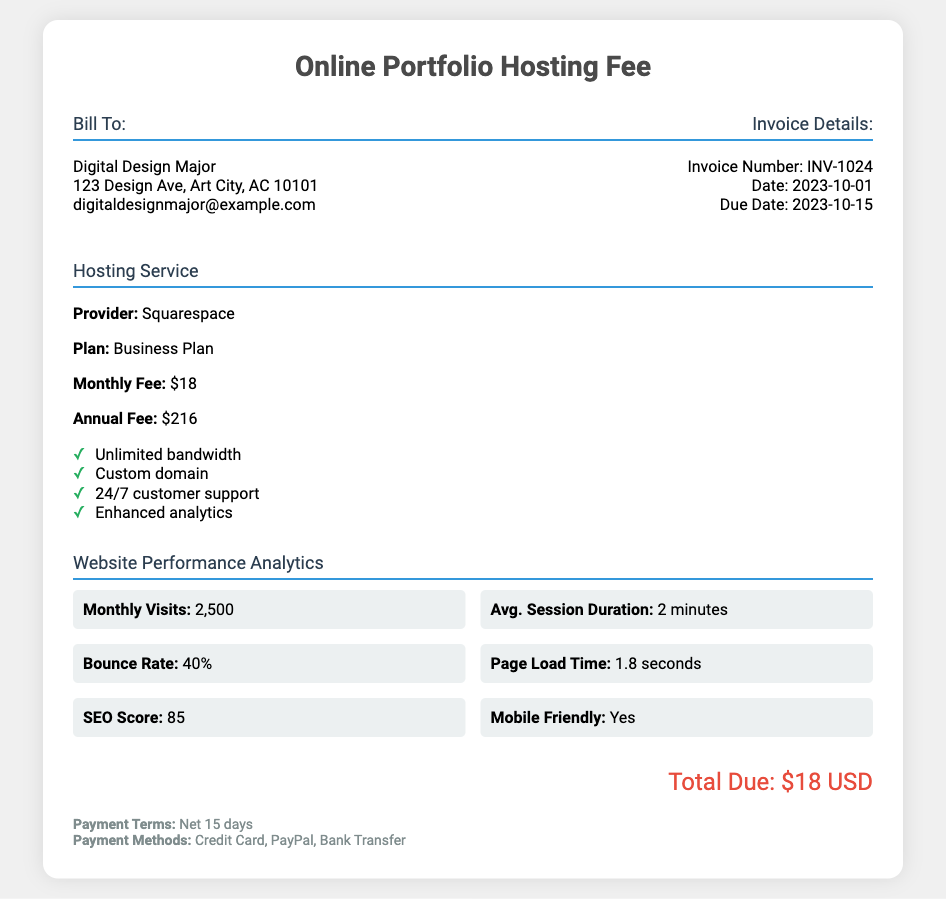What is the invoice number? The invoice number is specified in the document under Invoice Details.
Answer: INV-1024 What is the due date of the invoice? The due date is mentioned in the invoice details section.
Answer: 2023-10-15 Who is the hosting provider? The hosting provider is referred to in the hosting details section of the document.
Answer: Squarespace What is the bounce rate? The bounce rate is listed under Website Performance Analytics.
Answer: 40% How many monthly visits were reported? The number of monthly visits is provided in the website performance analytics section.
Answer: 2,500 What is the monthly fee for the hosting service? The monthly fee is detailed in the hosting details section of the bill.
Answer: $18 What is the total amount due? The total due is stated at the bottom of the document.
Answer: $18 USD What payment methods are accepted? The accepted payment methods are mentioned in the payment terms section.
Answer: Credit Card, PayPal, Bank Transfer Is the website mobile-friendly? Whether the website is mobile-friendly is stated in the website performance analytics section.
Answer: Yes 